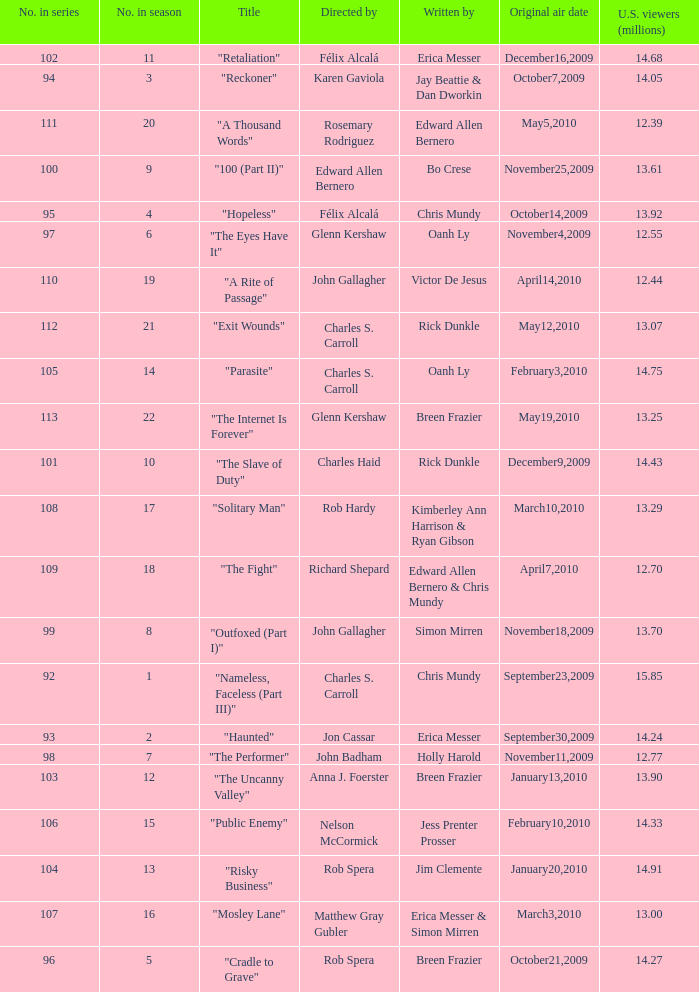What was the original air date for the episode with 13.92 million us viewers? October14,2009. 